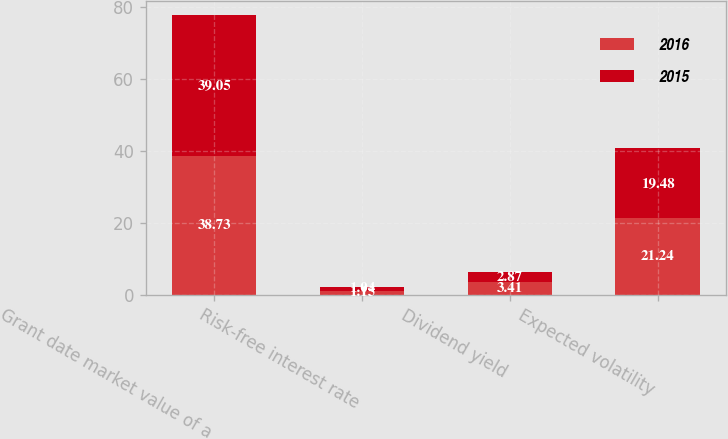Convert chart. <chart><loc_0><loc_0><loc_500><loc_500><stacked_bar_chart><ecel><fcel>Grant date market value of a<fcel>Risk-free interest rate<fcel>Dividend yield<fcel>Expected volatility<nl><fcel>2016<fcel>38.73<fcel>1.15<fcel>3.41<fcel>21.24<nl><fcel>2015<fcel>39.05<fcel>1.04<fcel>2.87<fcel>19.48<nl></chart> 